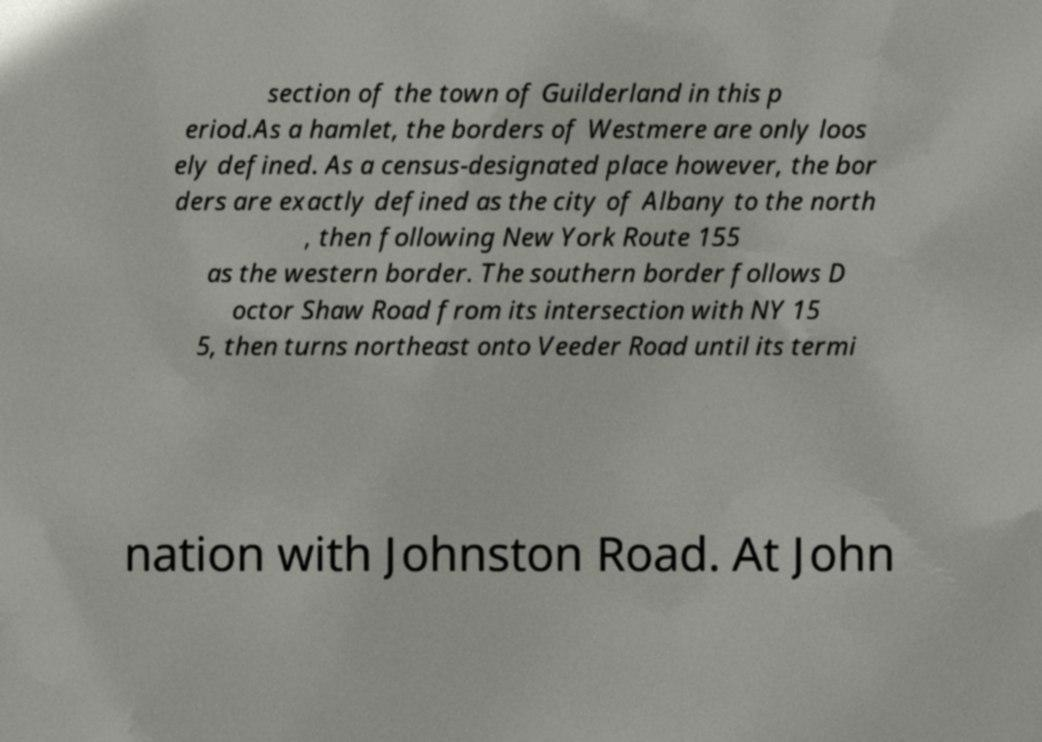Could you assist in decoding the text presented in this image and type it out clearly? section of the town of Guilderland in this p eriod.As a hamlet, the borders of Westmere are only loos ely defined. As a census-designated place however, the bor ders are exactly defined as the city of Albany to the north , then following New York Route 155 as the western border. The southern border follows D octor Shaw Road from its intersection with NY 15 5, then turns northeast onto Veeder Road until its termi nation with Johnston Road. At John 